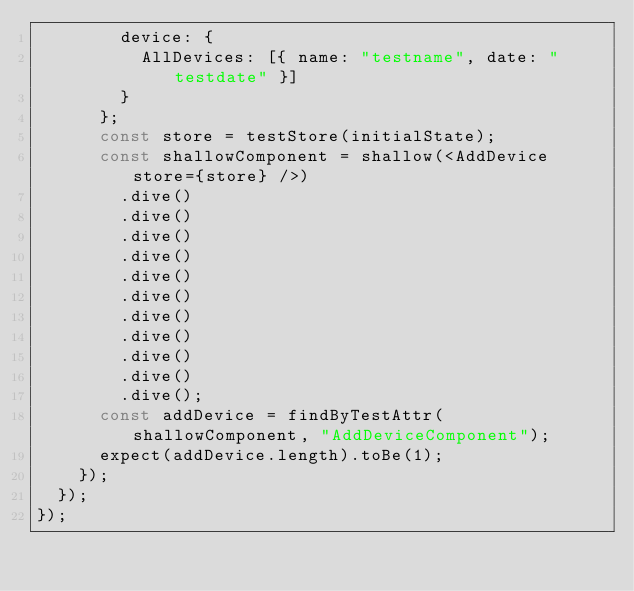Convert code to text. <code><loc_0><loc_0><loc_500><loc_500><_JavaScript_>        device: {
          AllDevices: [{ name: "testname", date: "testdate" }]
        }
      };
      const store = testStore(initialState);
      const shallowComponent = shallow(<AddDevice store={store} />)
        .dive()
        .dive()
        .dive()
        .dive()
        .dive()
        .dive()
        .dive()
        .dive()
        .dive()
        .dive()
        .dive();
      const addDevice = findByTestAttr(shallowComponent, "AddDeviceComponent");
      expect(addDevice.length).toBe(1);
    });
  });
});
</code> 